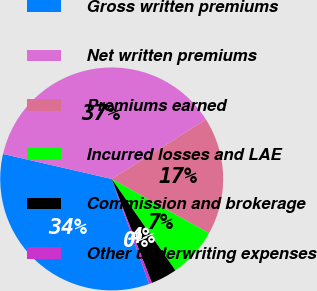<chart> <loc_0><loc_0><loc_500><loc_500><pie_chart><fcel>Gross written premiums<fcel>Net written premiums<fcel>Premiums earned<fcel>Incurred losses and LAE<fcel>Commission and brokerage<fcel>Other underwriting expenses<nl><fcel>34.05%<fcel>37.46%<fcel>17.05%<fcel>7.22%<fcel>3.82%<fcel>0.41%<nl></chart> 